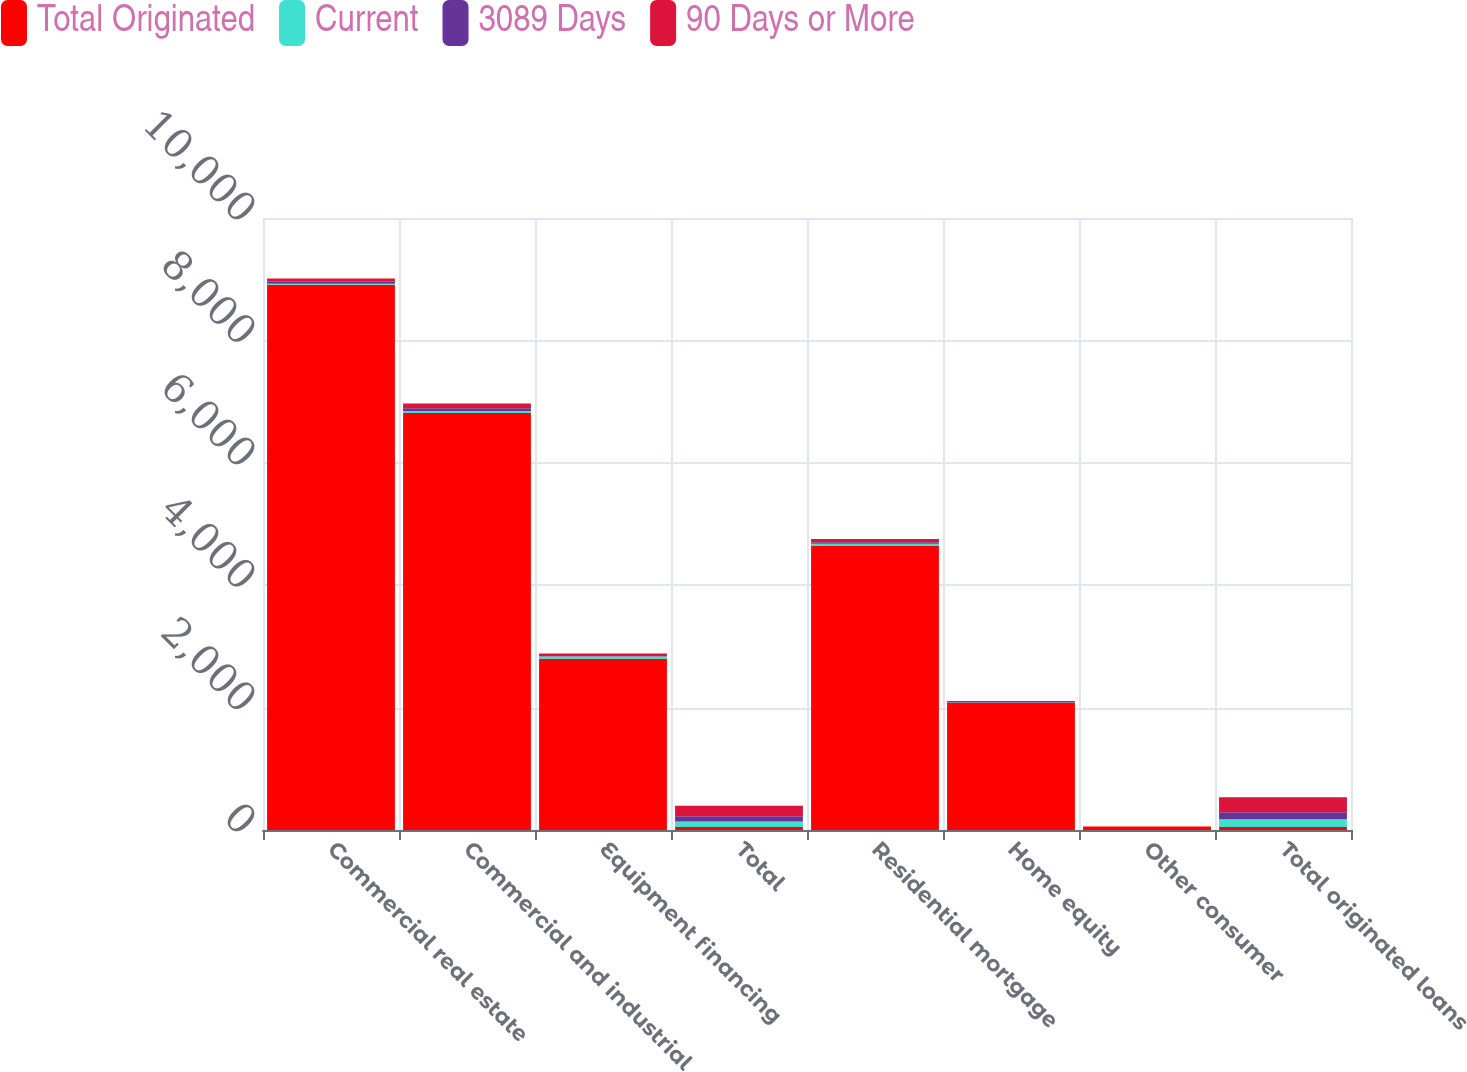Convert chart. <chart><loc_0><loc_0><loc_500><loc_500><stacked_bar_chart><ecel><fcel>Commercial real estate<fcel>Commercial and industrial<fcel>Equipment financing<fcel>Total<fcel>Residential mortgage<fcel>Home equity<fcel>Other consumer<fcel>Total originated loans<nl><fcel>Total Originated<fcel>8908<fcel>6814.9<fcel>2793.3<fcel>49<fcel>4647.3<fcel>2079.3<fcel>55.8<fcel>49<nl><fcel>Current<fcel>17.6<fcel>32.4<fcel>41<fcel>91<fcel>29.1<fcel>5<fcel>0.4<fcel>125.5<nl><fcel>3089 Days<fcel>34.7<fcel>43.8<fcel>4.7<fcel>83.2<fcel>25.1<fcel>8.6<fcel>0.1<fcel>117<nl><fcel>90 Days or More<fcel>52.3<fcel>76.2<fcel>45.7<fcel>174.2<fcel>54.2<fcel>13.6<fcel>0.5<fcel>242.5<nl></chart> 